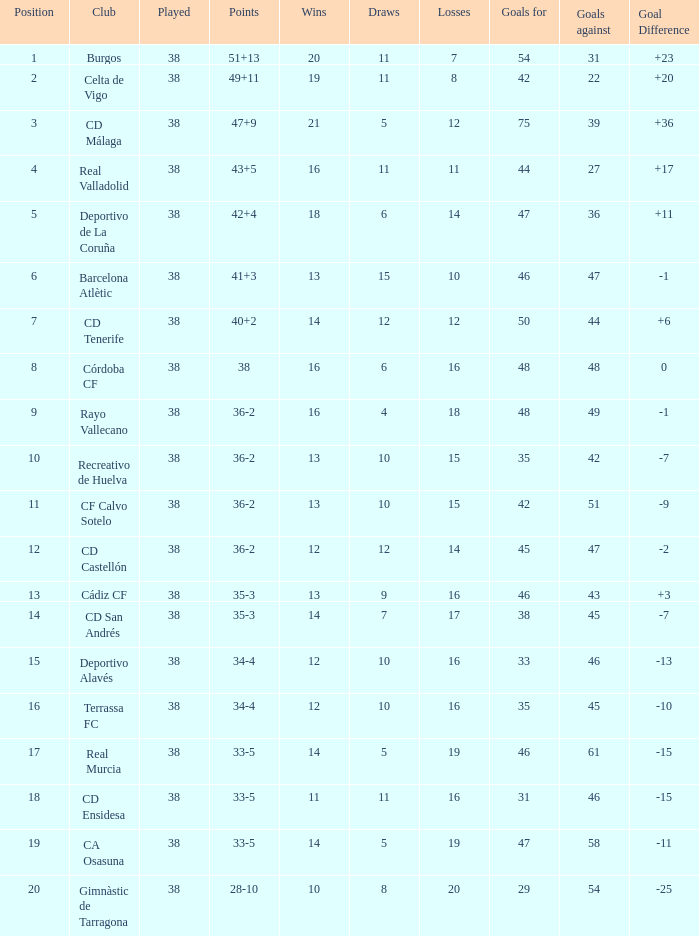Could you parse the entire table as a dict? {'header': ['Position', 'Club', 'Played', 'Points', 'Wins', 'Draws', 'Losses', 'Goals for', 'Goals against', 'Goal Difference'], 'rows': [['1', 'Burgos', '38', '51+13', '20', '11', '7', '54', '31', '+23'], ['2', 'Celta de Vigo', '38', '49+11', '19', '11', '8', '42', '22', '+20'], ['3', 'CD Málaga', '38', '47+9', '21', '5', '12', '75', '39', '+36'], ['4', 'Real Valladolid', '38', '43+5', '16', '11', '11', '44', '27', '+17'], ['5', 'Deportivo de La Coruña', '38', '42+4', '18', '6', '14', '47', '36', '+11'], ['6', 'Barcelona Atlètic', '38', '41+3', '13', '15', '10', '46', '47', '-1'], ['7', 'CD Tenerife', '38', '40+2', '14', '12', '12', '50', '44', '+6'], ['8', 'Córdoba CF', '38', '38', '16', '6', '16', '48', '48', '0'], ['9', 'Rayo Vallecano', '38', '36-2', '16', '4', '18', '48', '49', '-1'], ['10', 'Recreativo de Huelva', '38', '36-2', '13', '10', '15', '35', '42', '-7'], ['11', 'CF Calvo Sotelo', '38', '36-2', '13', '10', '15', '42', '51', '-9'], ['12', 'CD Castellón', '38', '36-2', '12', '12', '14', '45', '47', '-2'], ['13', 'Cádiz CF', '38', '35-3', '13', '9', '16', '46', '43', '+3'], ['14', 'CD San Andrés', '38', '35-3', '14', '7', '17', '38', '45', '-7'], ['15', 'Deportivo Alavés', '38', '34-4', '12', '10', '16', '33', '46', '-13'], ['16', 'Terrassa FC', '38', '34-4', '12', '10', '16', '35', '45', '-10'], ['17', 'Real Murcia', '38', '33-5', '14', '5', '19', '46', '61', '-15'], ['18', 'CD Ensidesa', '38', '33-5', '11', '11', '16', '31', '46', '-15'], ['19', 'CA Osasuna', '38', '33-5', '14', '5', '19', '47', '58', '-11'], ['20', 'Gimnàstic de Tarragona', '38', '28-10', '10', '8', '20', '29', '54', '-25']]} What is the mean loss when the goal is over 51 and victories exceed 14? None. 